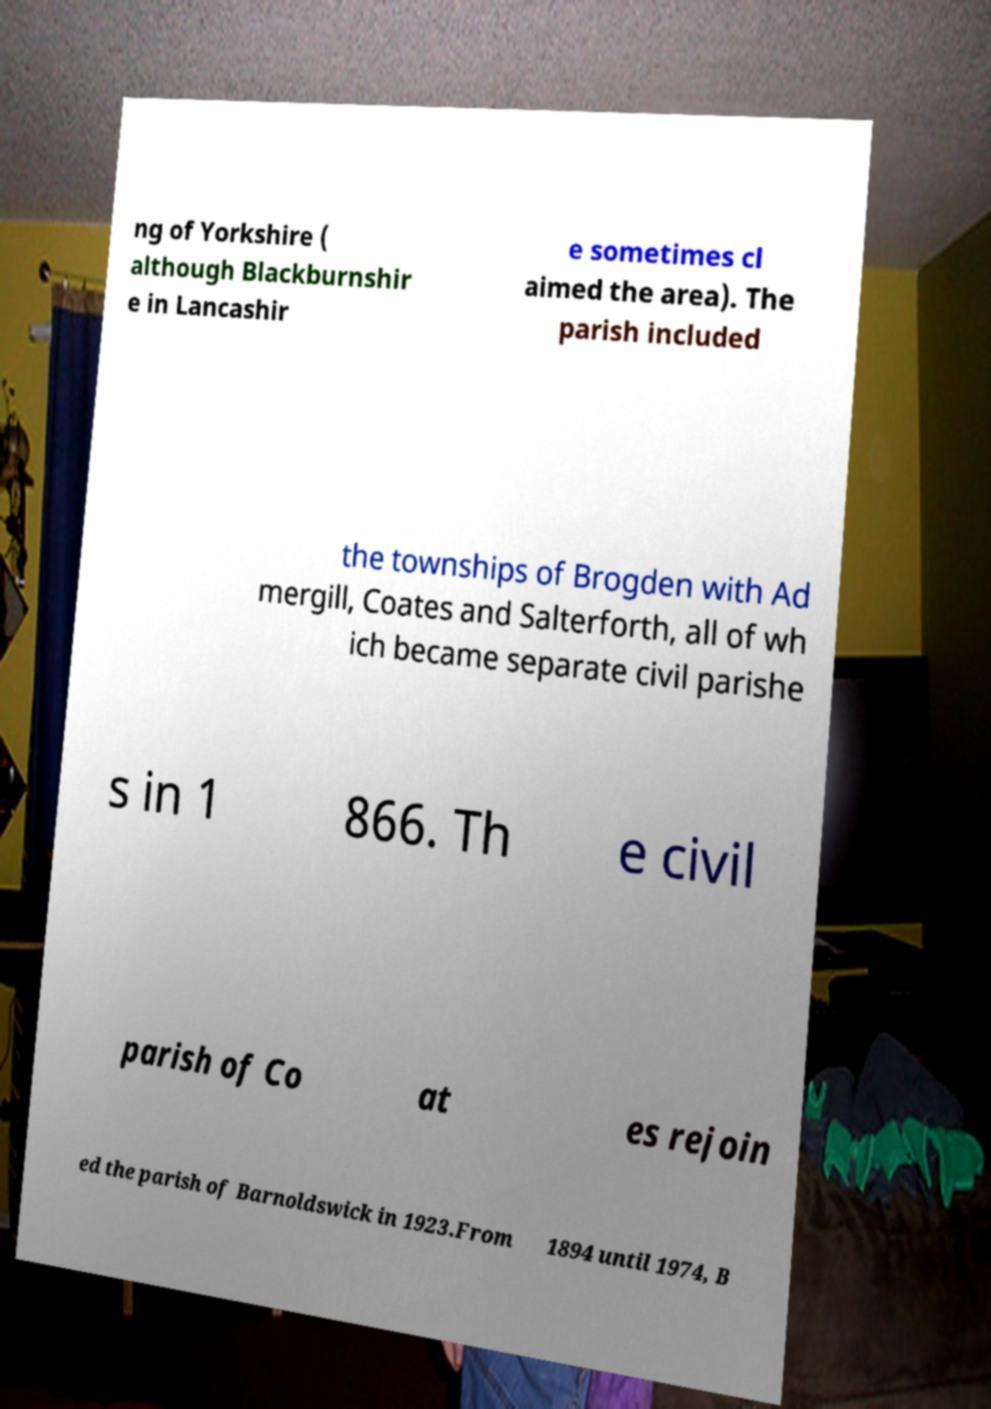Can you read and provide the text displayed in the image?This photo seems to have some interesting text. Can you extract and type it out for me? ng of Yorkshire ( although Blackburnshir e in Lancashir e sometimes cl aimed the area). The parish included the townships of Brogden with Ad mergill, Coates and Salterforth, all of wh ich became separate civil parishe s in 1 866. Th e civil parish of Co at es rejoin ed the parish of Barnoldswick in 1923.From 1894 until 1974, B 